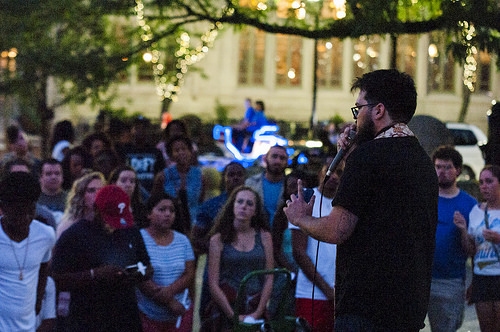<image>
Is there a man behind the woman? No. The man is not behind the woman. From this viewpoint, the man appears to be positioned elsewhere in the scene. 